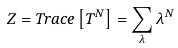Convert formula to latex. <formula><loc_0><loc_0><loc_500><loc_500>Z = T r a c e \left [ T ^ { N } \right ] = \sum _ { \lambda } \lambda ^ { N }</formula> 